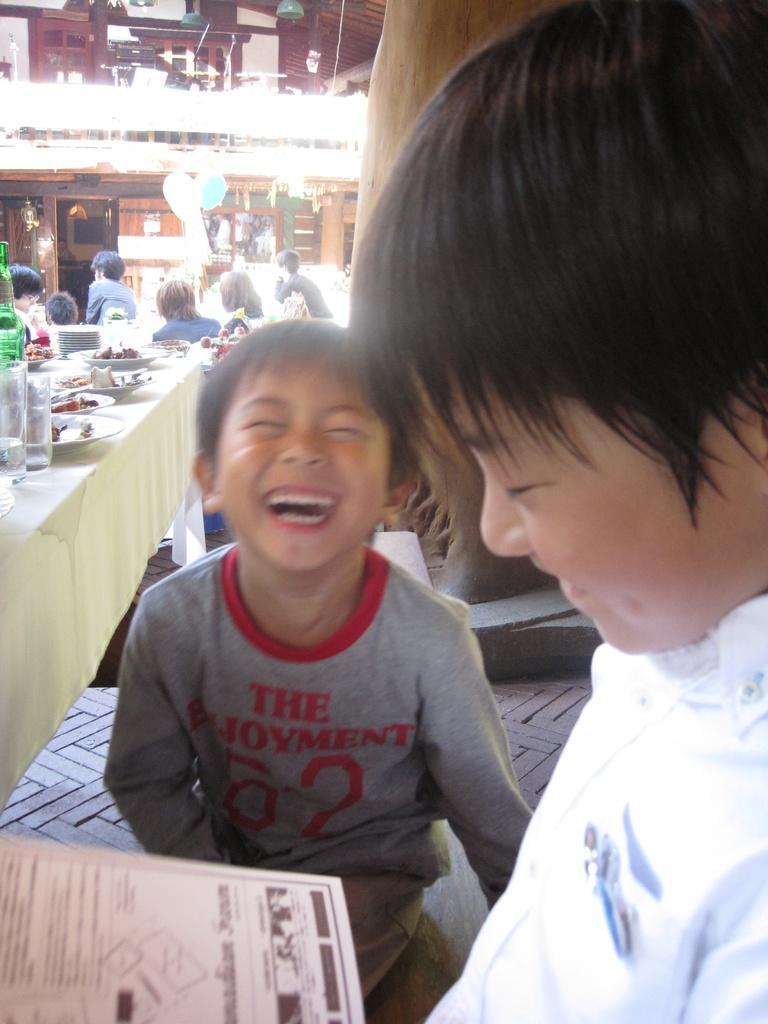How would you summarize this image in a sentence or two? In this image in the foreground there is one boy who is holding something, and beside him there is another boy who is laughing. And in the background there is a table, on the table there are some plates, glasses, bottles, and in the background there is a building some people, lights and some objects. At the bottom of the image there is floor. 